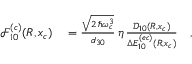<formula> <loc_0><loc_0><loc_500><loc_500>\begin{array} { r l } { \mathcal { F } _ { 1 0 } ^ { ( c ) } ( R , x _ { c } ) } & = \frac { \sqrt { 2 \, \hbar { \omega } _ { c } ^ { 3 } } } { d _ { 3 0 } } \, \eta \, \frac { \mathcal { D } _ { 1 0 } ( R , x _ { c } ) } { \Delta E _ { 1 0 } ^ { ( e c ) } ( R , x _ { c } ) } \quad , } \end{array}</formula> 